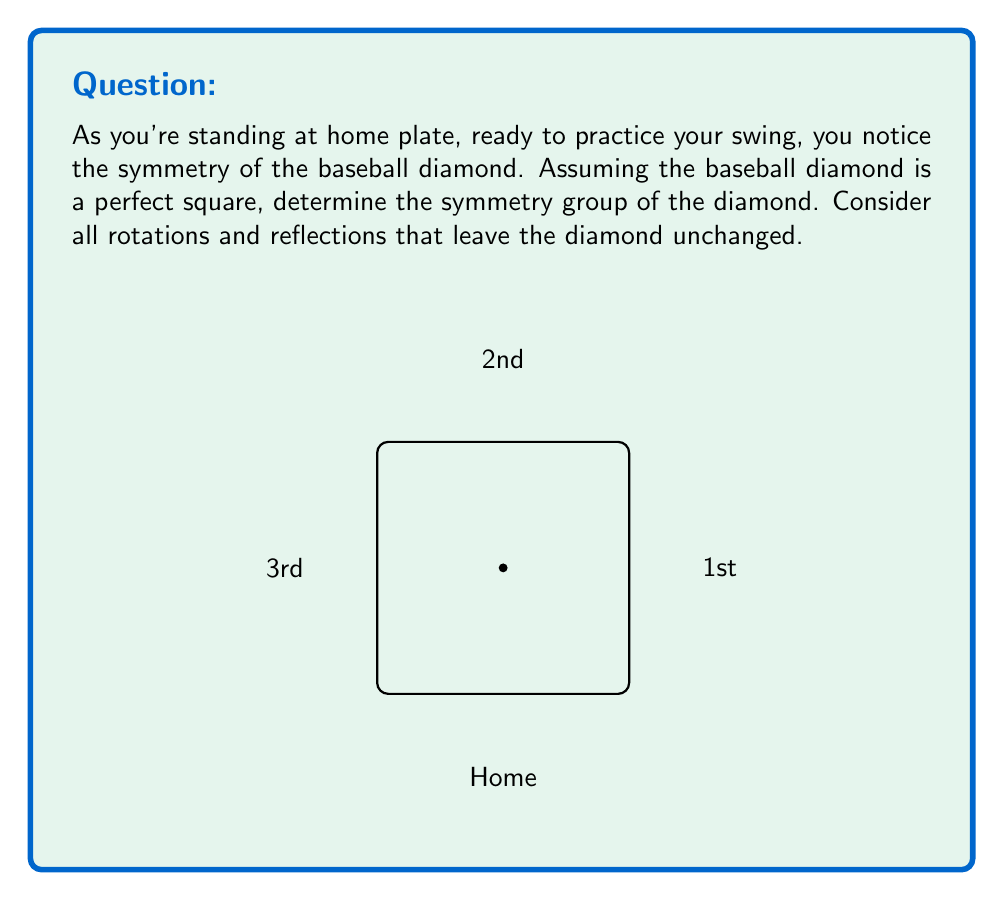Can you solve this math problem? Let's approach this step-by-step:

1) First, we need to identify all the symmetries of a square:

   a) Rotations: 
      - 0° (identity)
      - 90° clockwise
      - 180°
      - 270° clockwise (or 90° counterclockwise)

   b) Reflections:
      - Across the vertical line through the center
      - Across the horizontal line through the center
      - Across the diagonal from top-left to bottom-right
      - Across the diagonal from top-right to bottom-left

2) These symmetries form a group under composition. This group is known as the dihedral group of order 8, denoted as $D_4$ or $D_8$ (depending on the notation system).

3) The group has 8 elements in total:
   $$\{e, r, r^2, r^3, s, sr, sr^2, sr^3\}$$
   where $e$ is the identity, $r$ is a 90° rotation, and $s$ is a reflection.

4) The group operation table (Cayley table) for $D_4$ would look like this:

   $$\begin{array}{c|cccccccc}
   * & e & r & r^2 & r^3 & s & sr & sr^2 & sr^3 \\
   \hline
   e & e & r & r^2 & r^3 & s & sr & sr^2 & sr^3 \\
   r & r & r^2 & r^3 & e & sr & sr^2 & sr^3 & s \\
   r^2 & r^2 & r^3 & e & r & sr^2 & sr^3 & s & sr \\
   r^3 & r^3 & e & r & r^2 & sr^3 & s & sr & sr^2 \\
   s & s & sr^3 & sr^2 & sr & e & r^3 & r^2 & r \\
   sr & sr & s & sr^3 & sr^2 & r & e & r^3 & r^2 \\
   sr^2 & sr^2 & sr & s & sr^3 & r^2 & r & e & r^3 \\
   sr^3 & sr^3 & sr^2 & sr & s & r^3 & r^2 & r & e
   \end{array}$$

5) This group has the following properties:
   - It's non-abelian (not all elements commute)
   - It has order 8
   - It has 5 conjugacy classes
   - It has 5 subgroups

Therefore, the symmetry group of a baseball diamond is isomorphic to $D_4$.
Answer: $D_4$ 